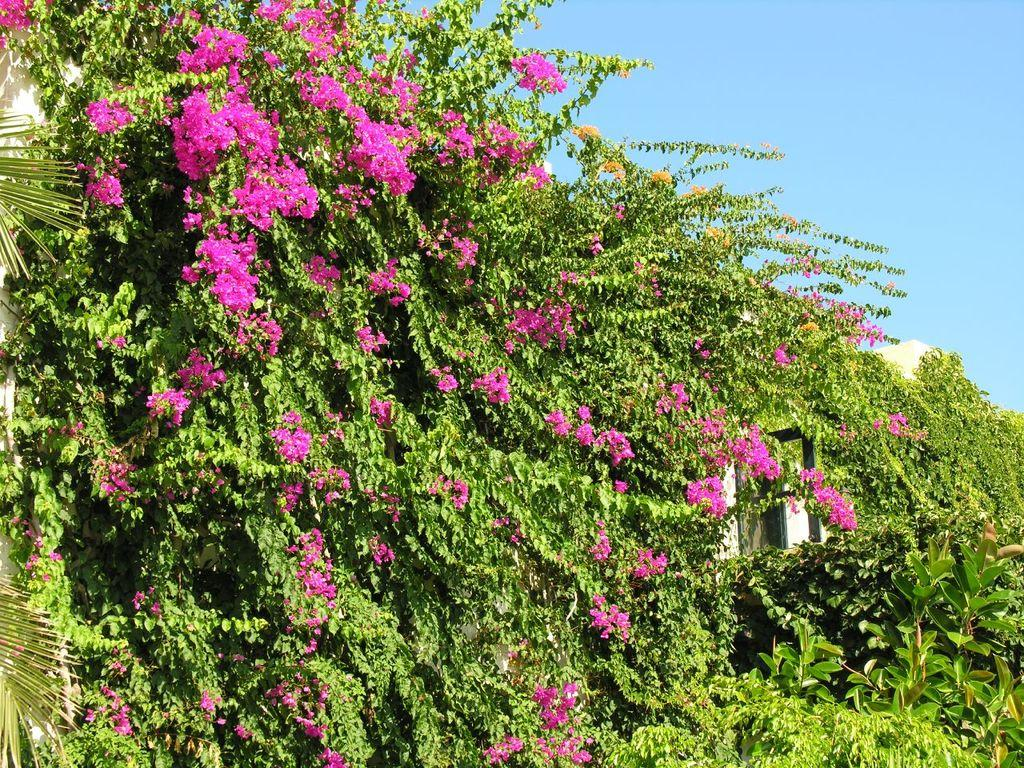What type of living organisms can be seen in the image? Plants and flowers are visible in the image. What is visible at the top of the image? The sky is visible at the top of the image. What is located behind the plants in the image? There is a building behind the plants in the image. What type of stamp can be seen on the building in the image? There is no stamp visible on the building in the image. What emotion is the plant feeling in the image? Plants do not have emotions, so it is not possible to determine the plant's feelings in the image. 